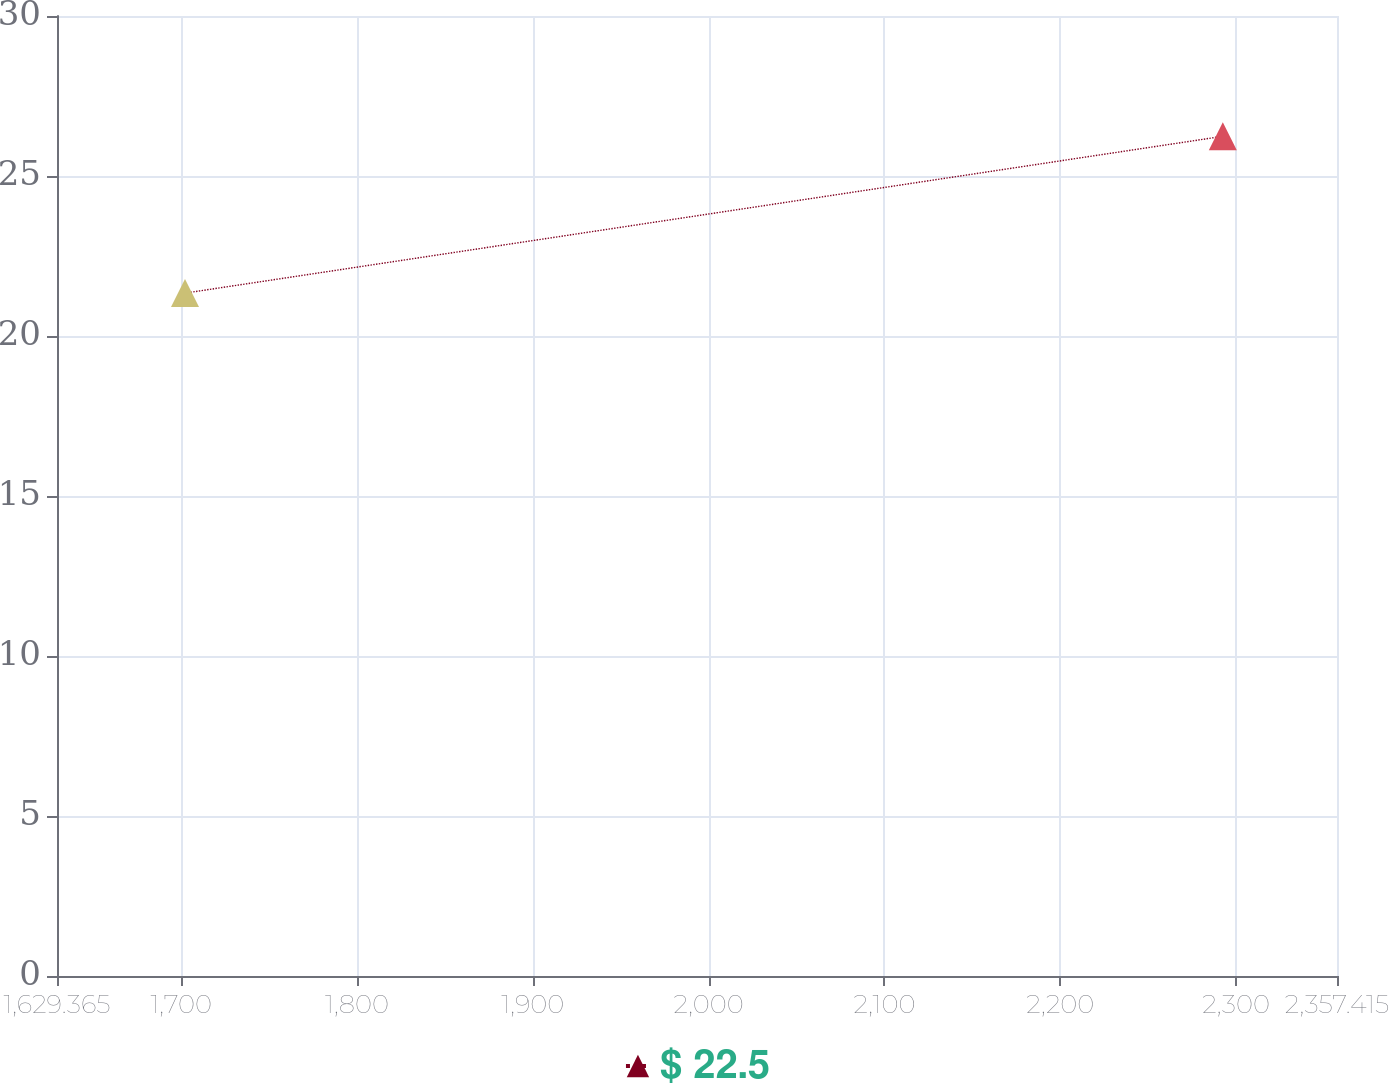Convert chart. <chart><loc_0><loc_0><loc_500><loc_500><line_chart><ecel><fcel>$ 22.5<nl><fcel>1702.17<fcel>21.34<nl><fcel>2292.46<fcel>26.24<nl><fcel>2361.34<fcel>18.09<nl><fcel>2430.22<fcel>19.06<nl></chart> 